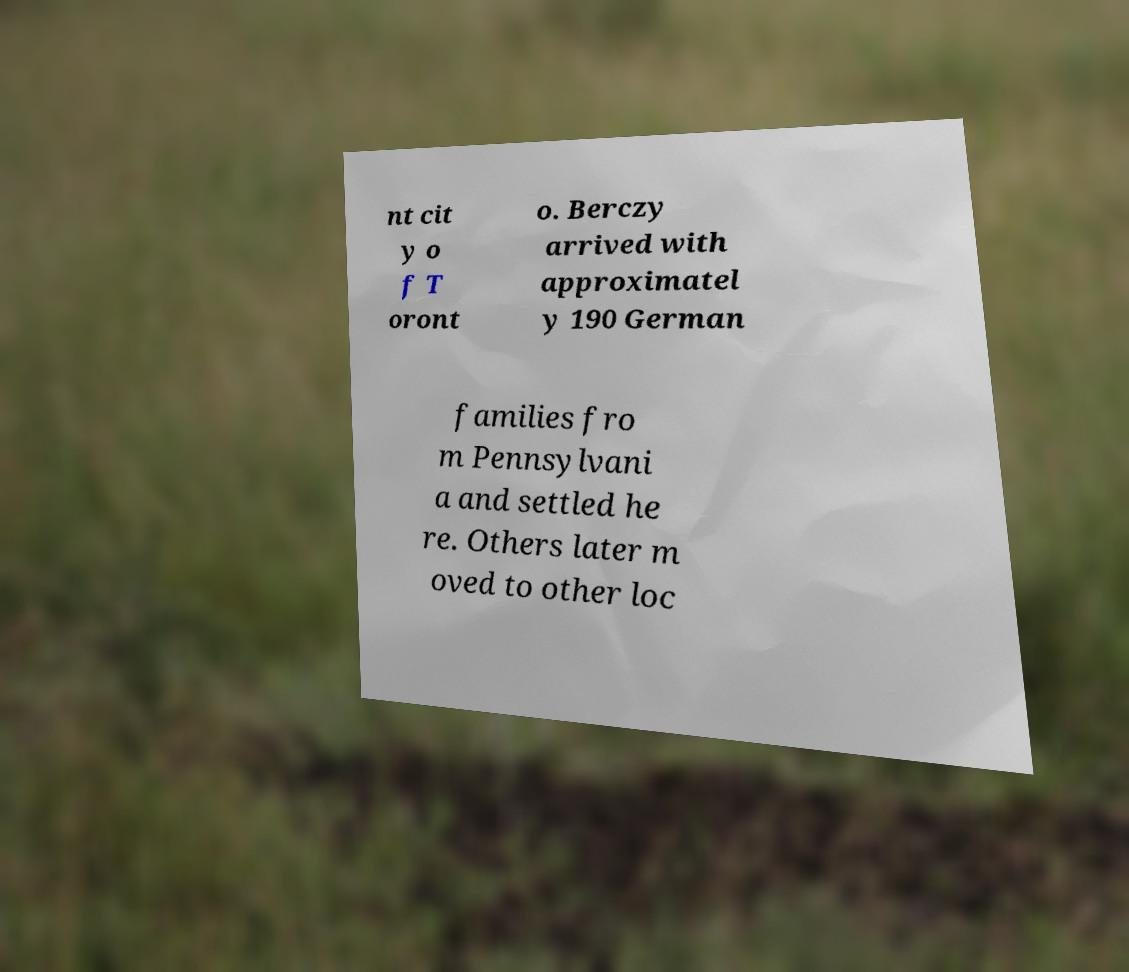Please identify and transcribe the text found in this image. nt cit y o f T oront o. Berczy arrived with approximatel y 190 German families fro m Pennsylvani a and settled he re. Others later m oved to other loc 